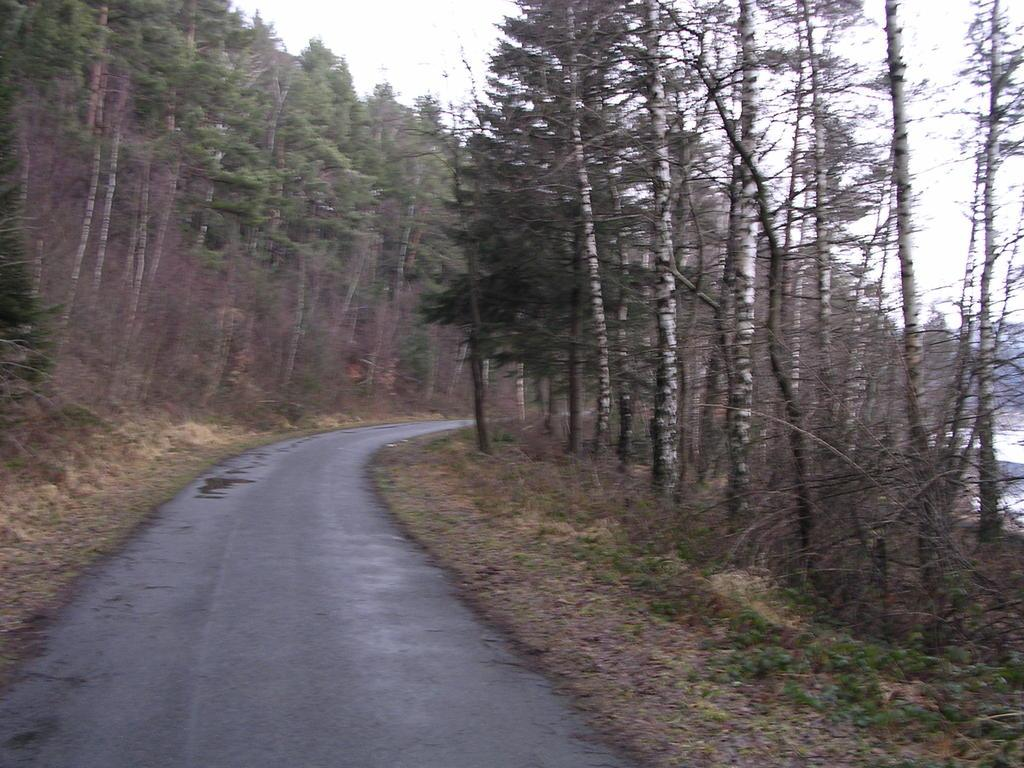What type of vegetation can be seen in the image? There is grass, plants, and trees in the image. What other elements are present in the image? There are stones and an unspecified object in the image. What can be seen in the sky in the image? The sky is visible in the image. Can you describe the setting of the image? The image may have been taken on a road. What is the chance of a circle appearing in the image? There is no mention of a circle in the image, so it cannot be determined if there is a chance of one appearing. 